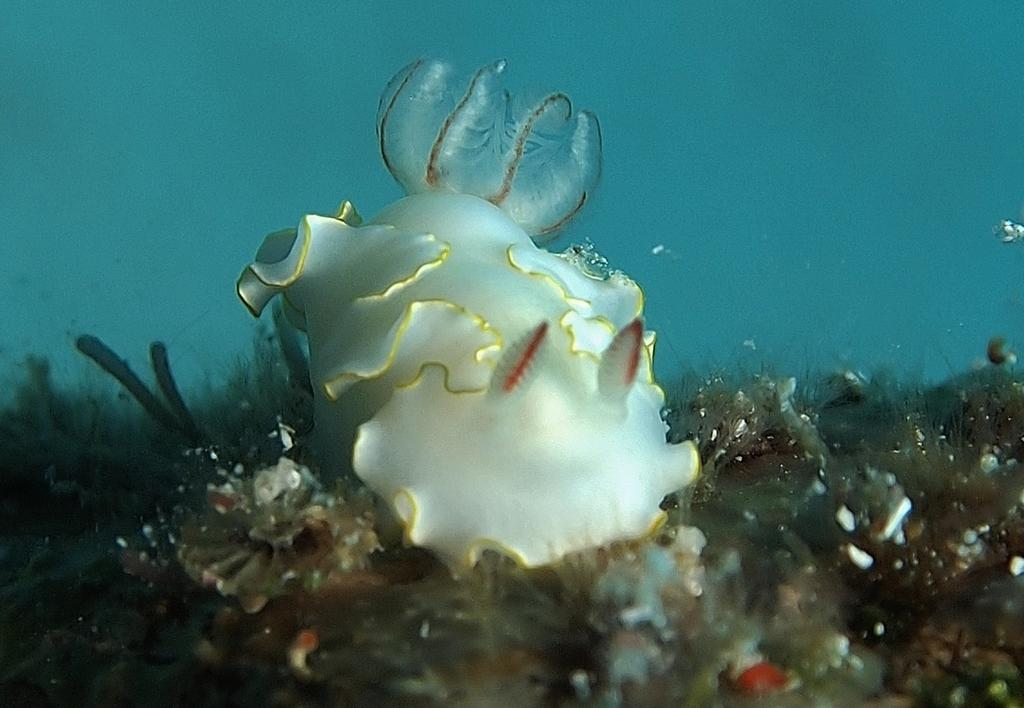What type of animal is present in the image? There is a fish in the image. What other marine creature can be seen in the image? There is a submarine species in the image. Where might this image have been taken? The image is likely taken in the ocean. What type of point is being made by the fish in the image? There is no indication in the image that the fish is making a point or communicating in any way. 